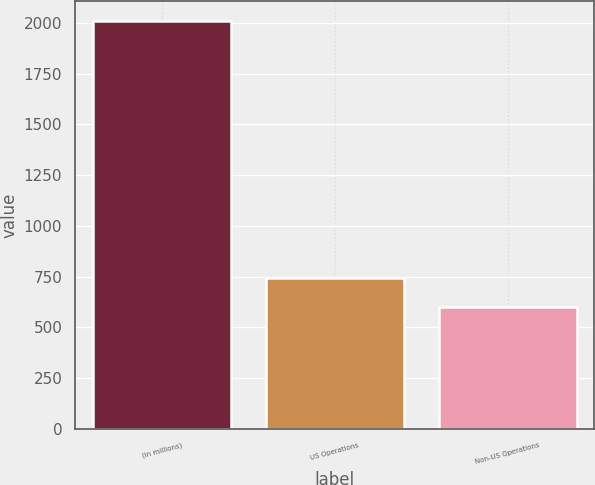Convert chart. <chart><loc_0><loc_0><loc_500><loc_500><bar_chart><fcel>(in millions)<fcel>US Operations<fcel>Non-US Operations<nl><fcel>2007<fcel>741.51<fcel>600.9<nl></chart> 